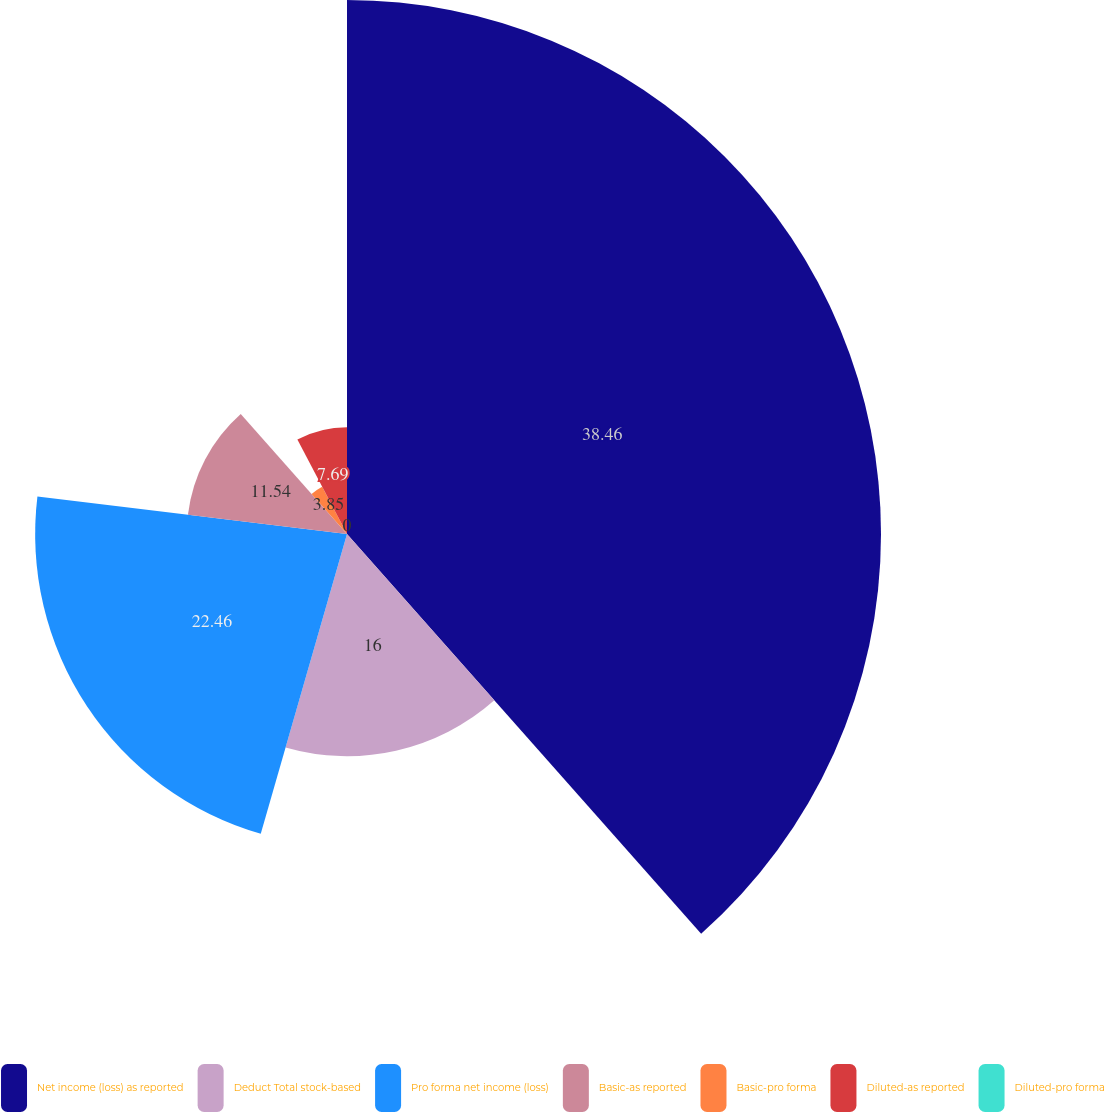<chart> <loc_0><loc_0><loc_500><loc_500><pie_chart><fcel>Net income (loss) as reported<fcel>Deduct Total stock-based<fcel>Pro forma net income (loss)<fcel>Basic-as reported<fcel>Basic-pro forma<fcel>Diluted-as reported<fcel>Diluted-pro forma<nl><fcel>38.46%<fcel>16.0%<fcel>22.46%<fcel>11.54%<fcel>3.85%<fcel>7.69%<fcel>0.0%<nl></chart> 